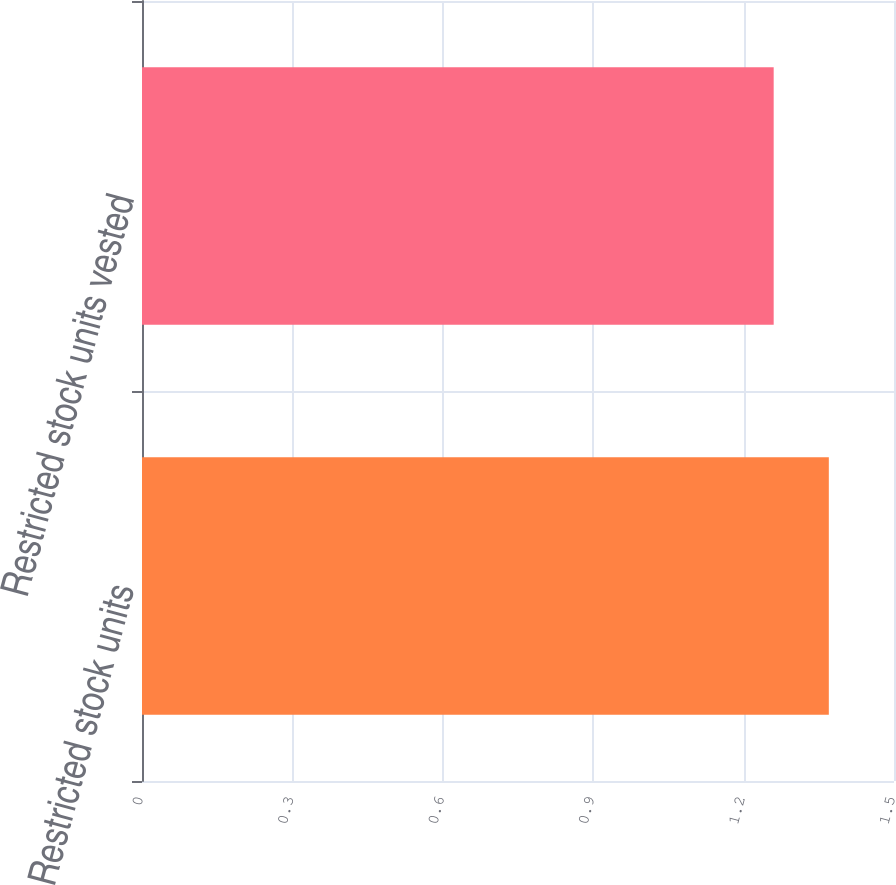Convert chart to OTSL. <chart><loc_0><loc_0><loc_500><loc_500><bar_chart><fcel>Restricted stock units<fcel>Restricted stock units vested<nl><fcel>1.37<fcel>1.26<nl></chart> 